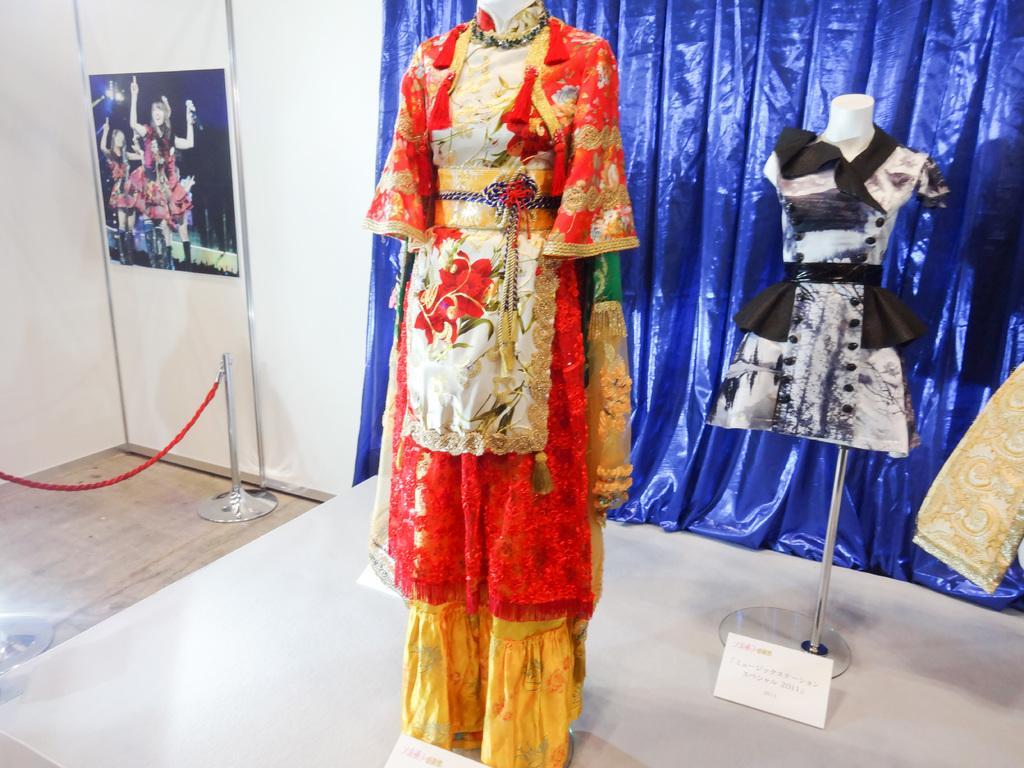Please provide a concise description of this image. In this image there is a wall, there is poster on the wall, there are persons on the poster, there is a stand on the floor, there is a rope, there is an object truncated towards the left of the image, there is a cloth truncated, there are dress, there is a board on the surface, there is a board truncated, there is an object truncated towards the right of the image. 